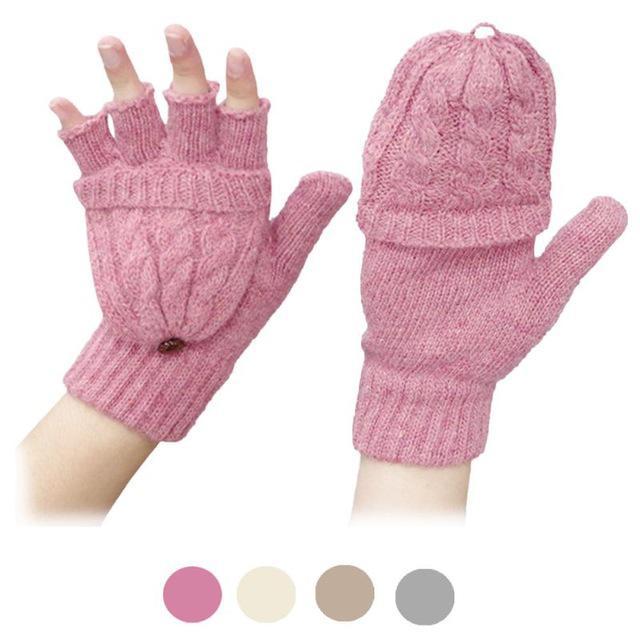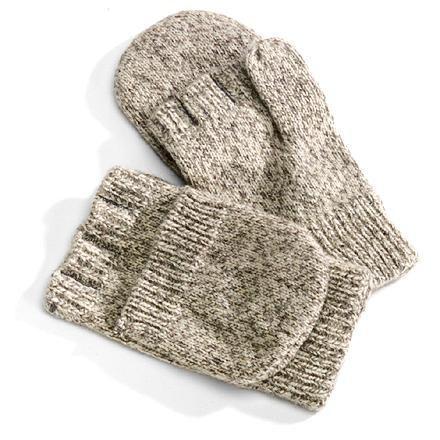The first image is the image on the left, the second image is the image on the right. Considering the images on both sides, is "The left image shows a pair of pink half-finger gloves with a mitten flap, and the right shows the same type of fashion in heather yarn, but only one shows gloves worn by hands." valid? Answer yes or no. Yes. The first image is the image on the left, the second image is the image on the right. Analyze the images presented: Is the assertion "There is a set of pink convertible mittens in one image." valid? Answer yes or no. Yes. 